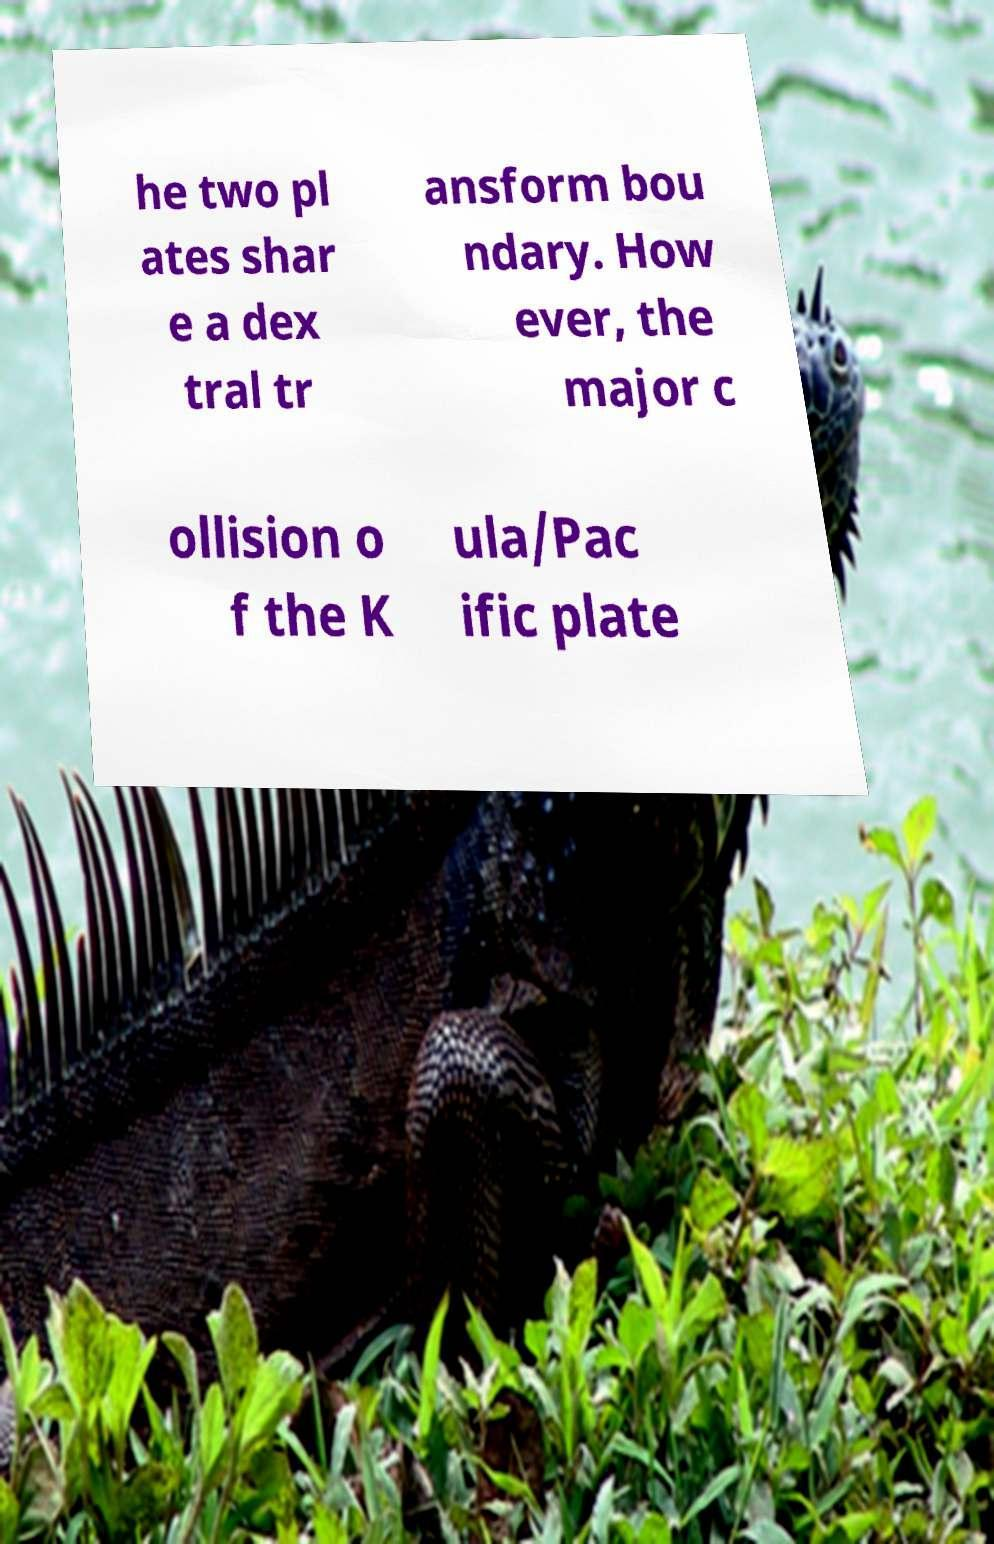Please read and relay the text visible in this image. What does it say? he two pl ates shar e a dex tral tr ansform bou ndary. How ever, the major c ollision o f the K ula/Pac ific plate 